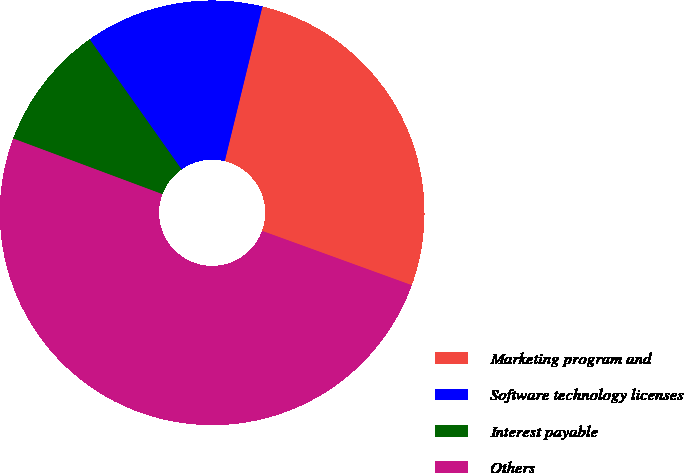Convert chart to OTSL. <chart><loc_0><loc_0><loc_500><loc_500><pie_chart><fcel>Marketing program and<fcel>Software technology licenses<fcel>Interest payable<fcel>Others<nl><fcel>26.74%<fcel>13.59%<fcel>9.53%<fcel>50.14%<nl></chart> 